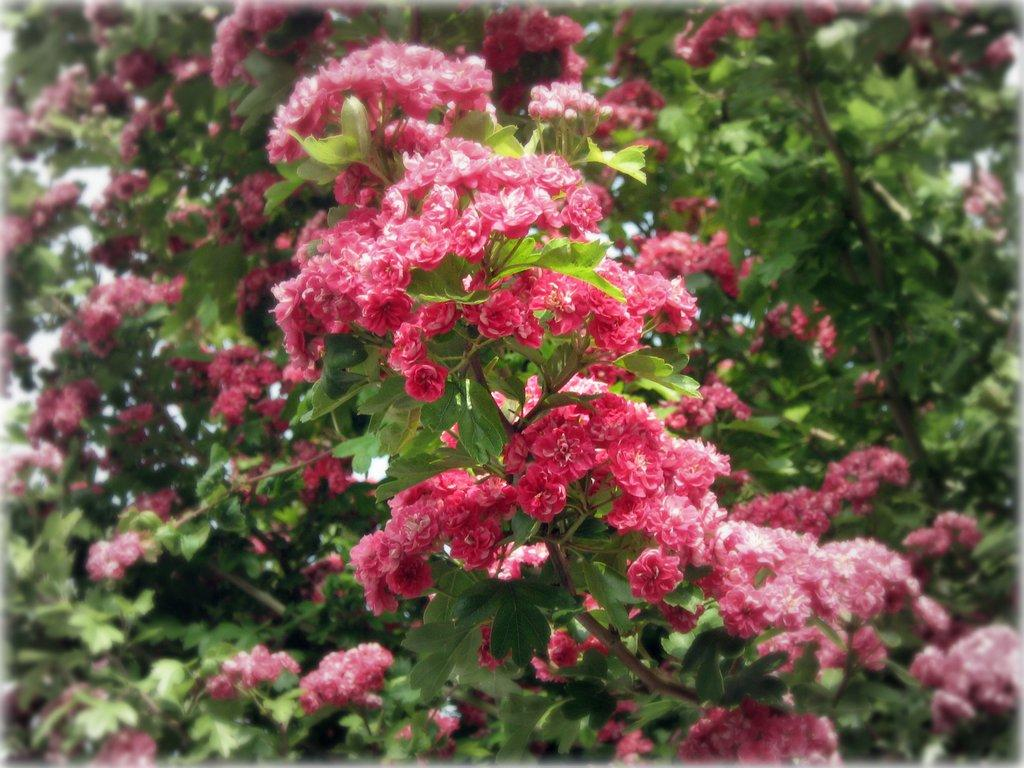What is the main subject of the image? The main subject of the image is many plants. What can be observed about the plants in the image? The plants have many flowers. What day of the week is it in the image? The day of the week is not mentioned or depicted in the image. What action are the plants performing in the image? Plants do not perform actions; they are stationary and grow. 